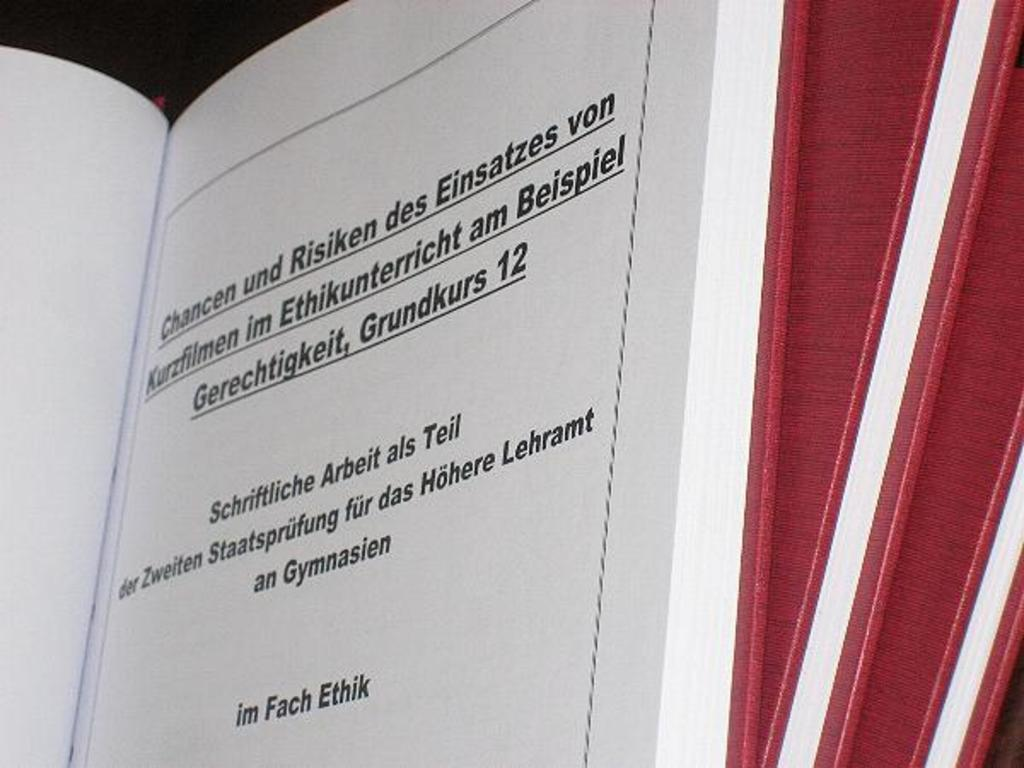<image>
Write a terse but informative summary of the picture. Three thin hardcover books contain the phrase "im Fach Ethik" on the title page. 